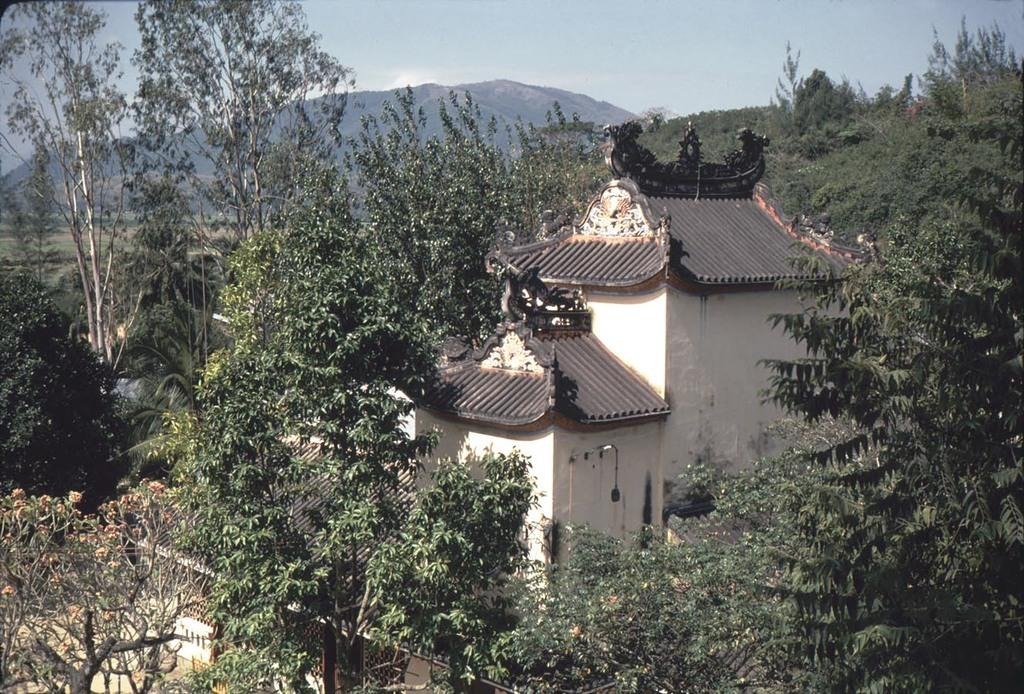What is the main subject in the center of the image? There is a building in the center of the image. What type of natural elements can be seen in the image? There are trees visible in the image. What can be seen in the distance in the background of the image? There are hills in the background of the image. What is visible above the hills in the image? The sky is visible in the background of the image. What color is the crayon used to draw the string on the kitty in the image? There is no kitty, crayon, or string present in the image. 